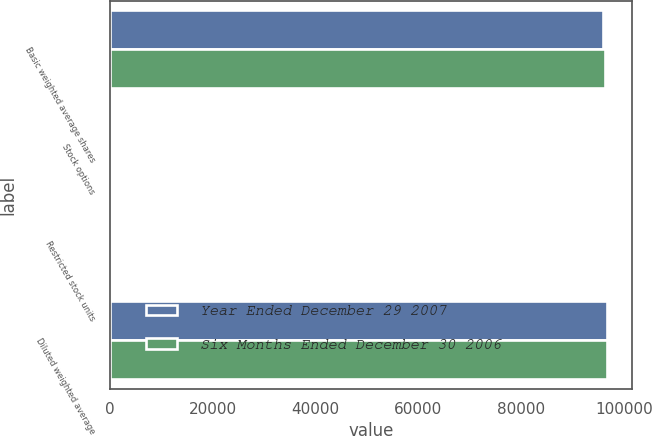Convert chart. <chart><loc_0><loc_0><loc_500><loc_500><stacked_bar_chart><ecel><fcel>Basic weighted average shares<fcel>Stock options<fcel>Restricted stock units<fcel>Diluted weighted average<nl><fcel>Year Ended December 29 2007<fcel>95936<fcel>278<fcel>527<fcel>96741<nl><fcel>Six Months Ended December 30 2006<fcel>96309<fcel>31<fcel>280<fcel>96620<nl></chart> 